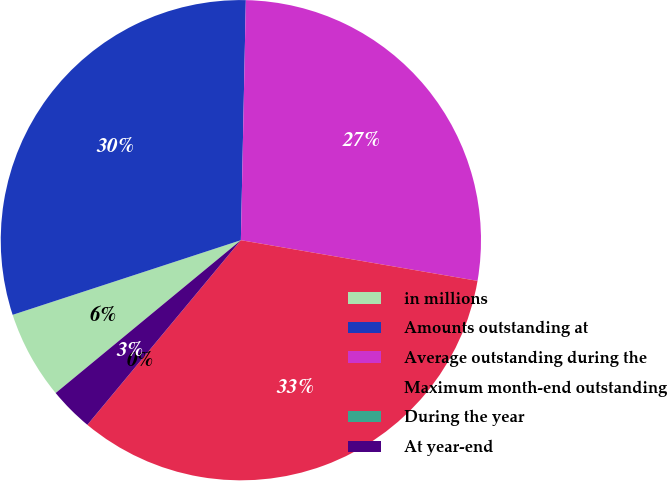Convert chart. <chart><loc_0><loc_0><loc_500><loc_500><pie_chart><fcel>in millions<fcel>Amounts outstanding at<fcel>Average outstanding during the<fcel>Maximum month-end outstanding<fcel>During the year<fcel>At year-end<nl><fcel>5.95%<fcel>30.36%<fcel>27.38%<fcel>33.33%<fcel>0.0%<fcel>2.98%<nl></chart> 